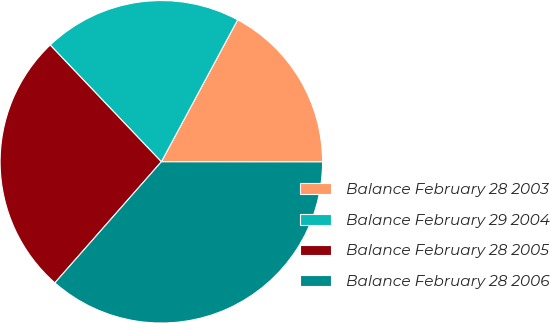Convert chart to OTSL. <chart><loc_0><loc_0><loc_500><loc_500><pie_chart><fcel>Balance February 28 2003<fcel>Balance February 29 2004<fcel>Balance February 28 2005<fcel>Balance February 28 2006<nl><fcel>17.16%<fcel>19.96%<fcel>26.41%<fcel>36.47%<nl></chart> 